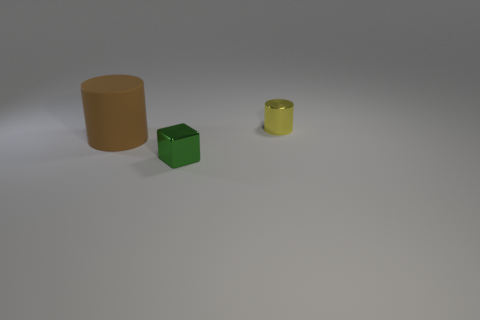Add 2 small cubes. How many objects exist? 5 Subtract all cylinders. How many objects are left? 1 Add 3 shiny things. How many shiny things exist? 5 Subtract 0 brown spheres. How many objects are left? 3 Subtract all small green metallic objects. Subtract all brown shiny things. How many objects are left? 2 Add 3 brown matte objects. How many brown matte objects are left? 4 